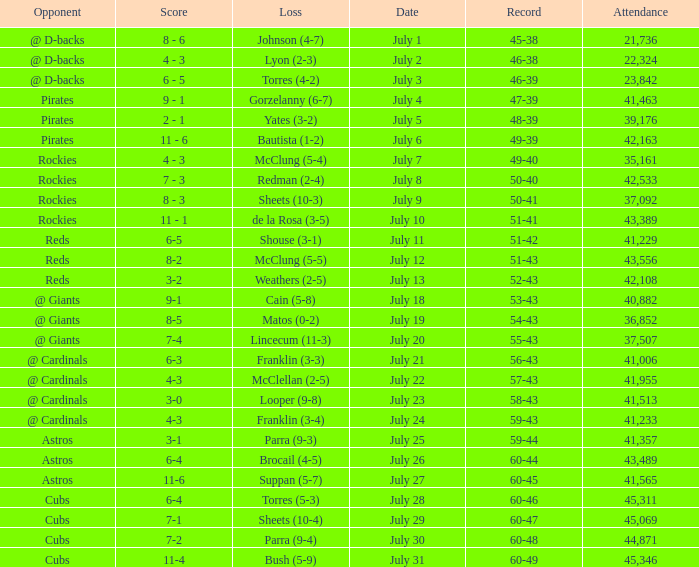What's the attendance of the game where there was a Loss of Yates (3-2)? 39176.0. 